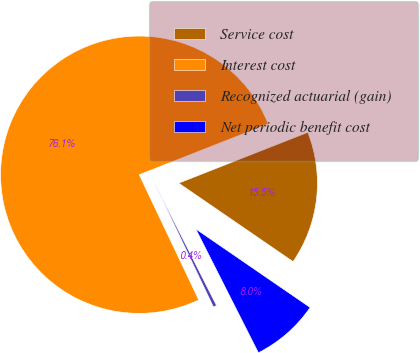<chart> <loc_0><loc_0><loc_500><loc_500><pie_chart><fcel>Service cost<fcel>Interest cost<fcel>Recognized actuarial (gain)<fcel>Net periodic benefit cost<nl><fcel>15.54%<fcel>76.1%<fcel>0.39%<fcel>7.97%<nl></chart> 